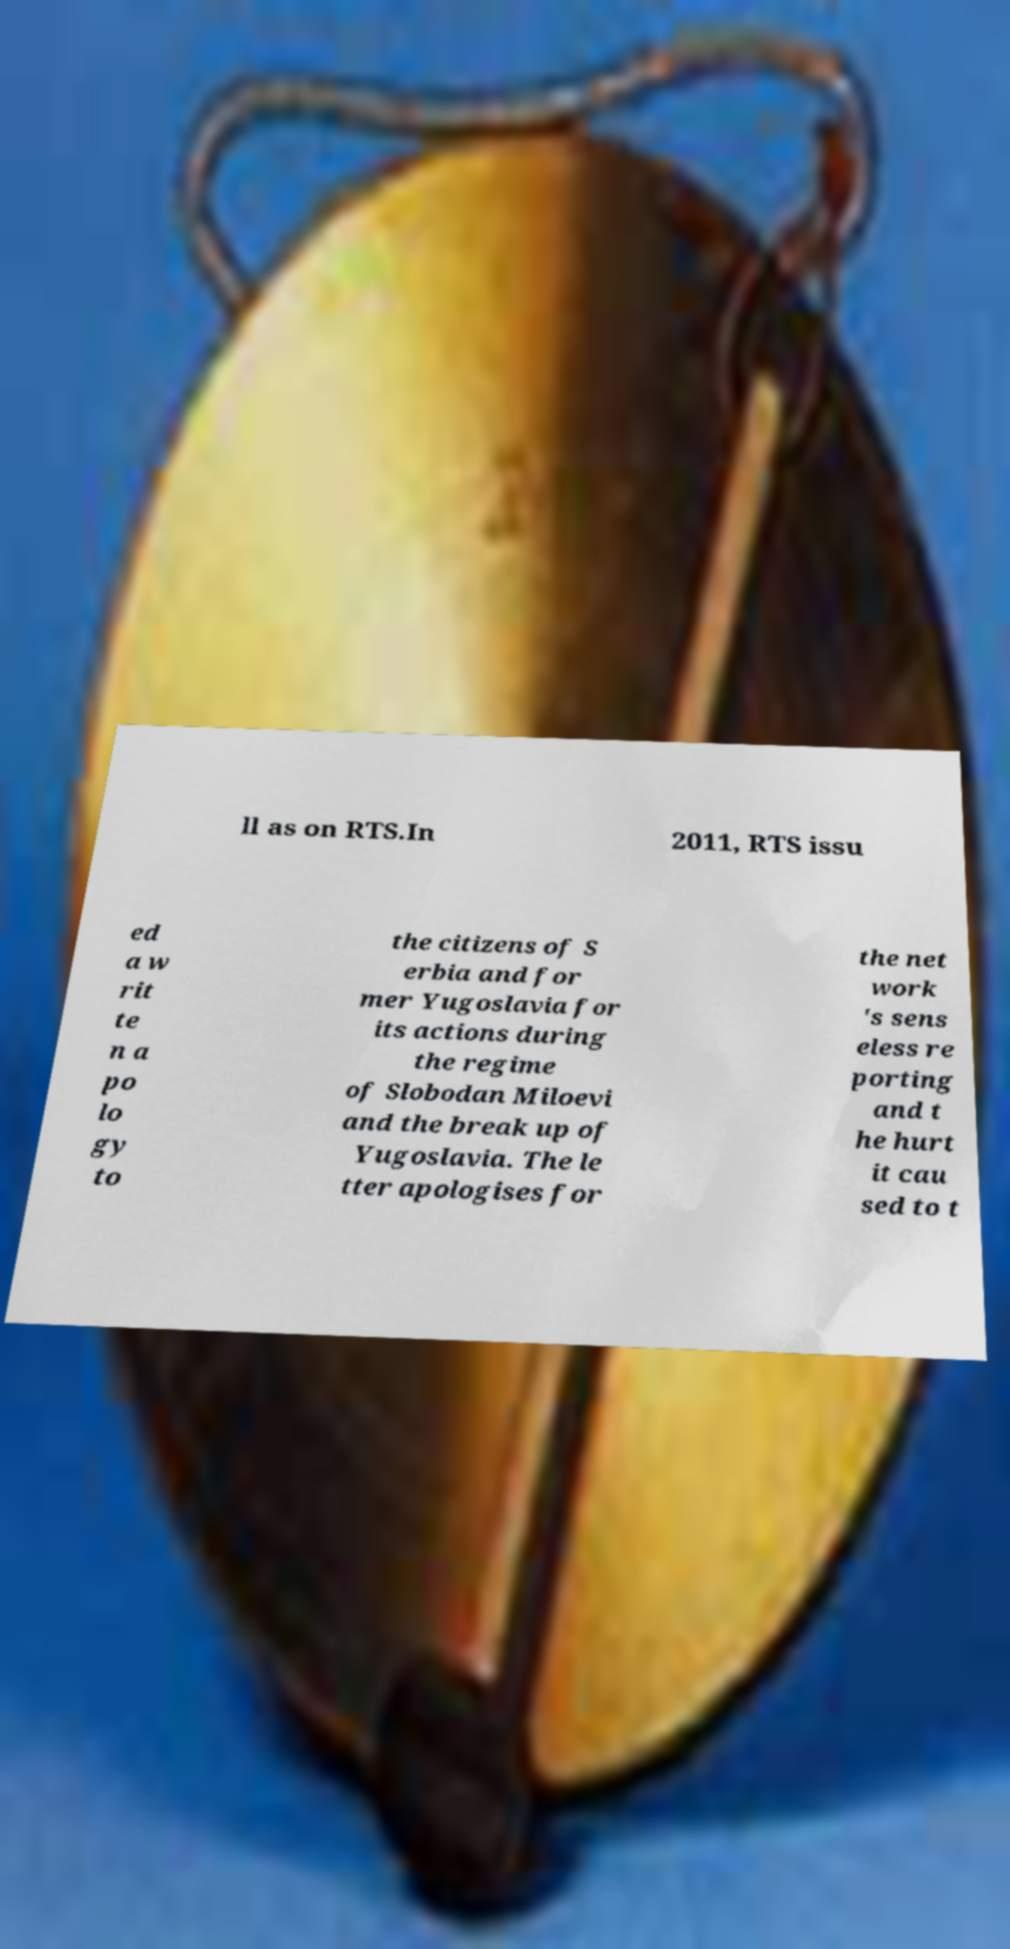Can you read and provide the text displayed in the image?This photo seems to have some interesting text. Can you extract and type it out for me? ll as on RTS.In 2011, RTS issu ed a w rit te n a po lo gy to the citizens of S erbia and for mer Yugoslavia for its actions during the regime of Slobodan Miloevi and the break up of Yugoslavia. The le tter apologises for the net work 's sens eless re porting and t he hurt it cau sed to t 